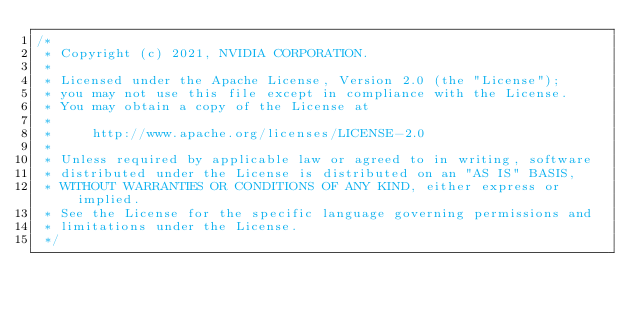<code> <loc_0><loc_0><loc_500><loc_500><_Cuda_>/*
 * Copyright (c) 2021, NVIDIA CORPORATION.
 *
 * Licensed under the Apache License, Version 2.0 (the "License");
 * you may not use this file except in compliance with the License.
 * You may obtain a copy of the License at
 *
 *     http://www.apache.org/licenses/LICENSE-2.0
 *
 * Unless required by applicable law or agreed to in writing, software
 * distributed under the License is distributed on an "AS IS" BASIS,
 * WITHOUT WARRANTIES OR CONDITIONS OF ANY KIND, either express or implied.
 * See the License for the specific language governing permissions and
 * limitations under the License.
 */
</code> 